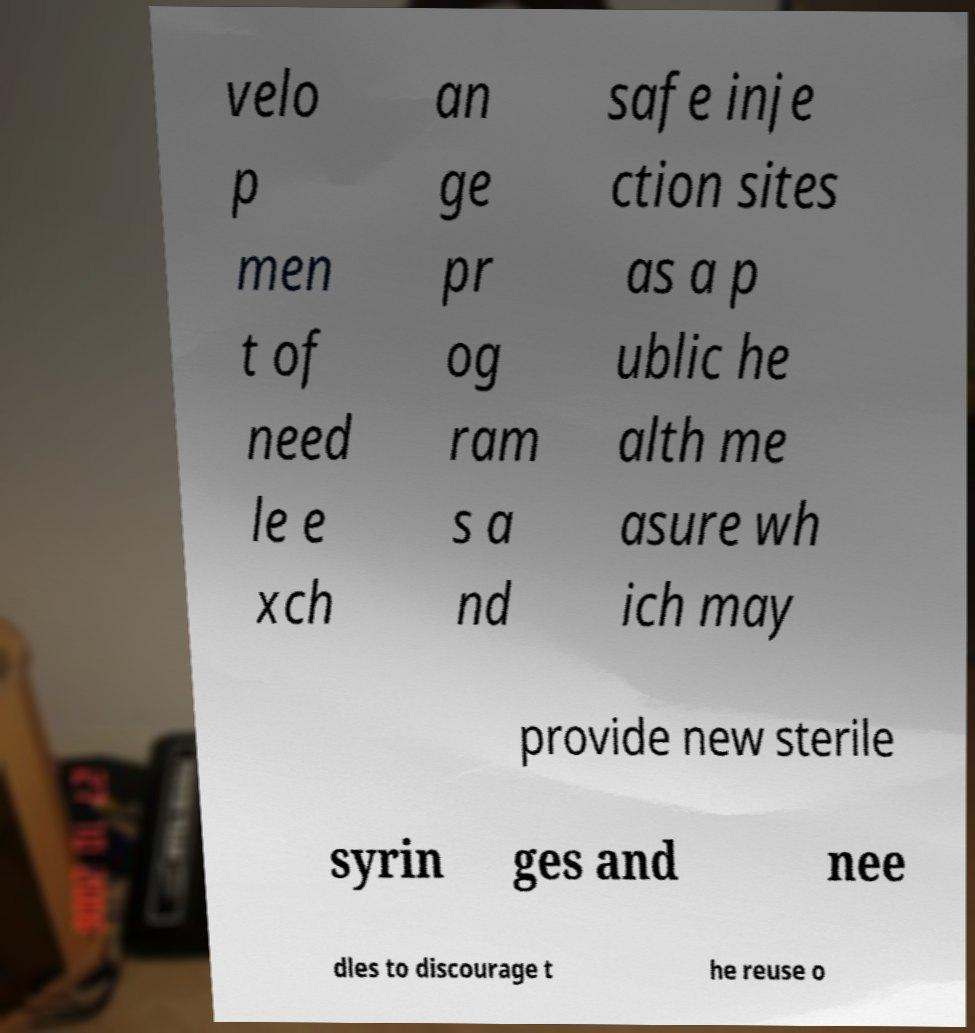There's text embedded in this image that I need extracted. Can you transcribe it verbatim? velo p men t of need le e xch an ge pr og ram s a nd safe inje ction sites as a p ublic he alth me asure wh ich may provide new sterile syrin ges and nee dles to discourage t he reuse o 